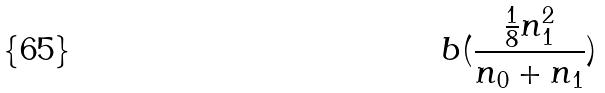Convert formula to latex. <formula><loc_0><loc_0><loc_500><loc_500>b ( \frac { \frac { 1 } { 8 } n _ { 1 } ^ { 2 } } { n _ { 0 } + n _ { 1 } } )</formula> 